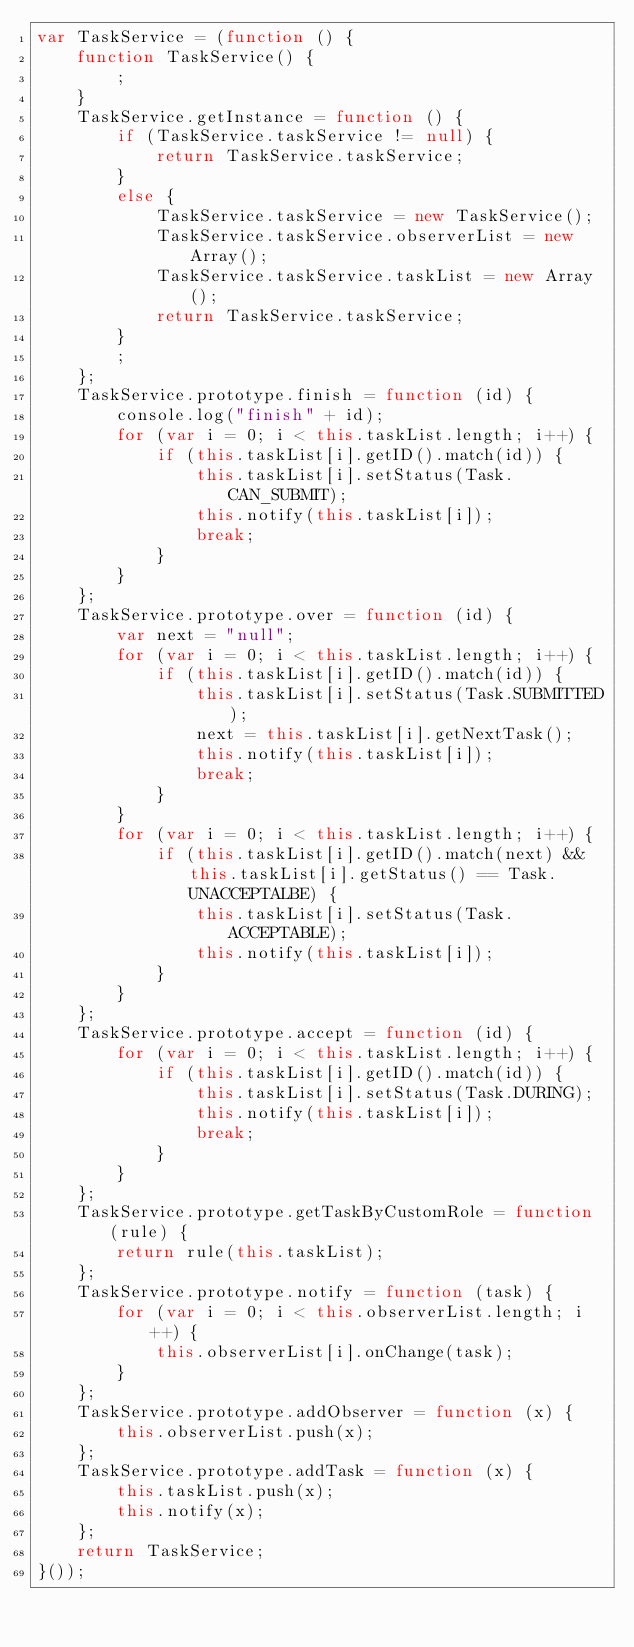Convert code to text. <code><loc_0><loc_0><loc_500><loc_500><_JavaScript_>var TaskService = (function () {
    function TaskService() {
        ;
    }
    TaskService.getInstance = function () {
        if (TaskService.taskService != null) {
            return TaskService.taskService;
        }
        else {
            TaskService.taskService = new TaskService();
            TaskService.taskService.observerList = new Array();
            TaskService.taskService.taskList = new Array();
            return TaskService.taskService;
        }
        ;
    };
    TaskService.prototype.finish = function (id) {
        console.log("finish" + id);
        for (var i = 0; i < this.taskList.length; i++) {
            if (this.taskList[i].getID().match(id)) {
                this.taskList[i].setStatus(Task.CAN_SUBMIT);
                this.notify(this.taskList[i]);
                break;
            }
        }
    };
    TaskService.prototype.over = function (id) {
        var next = "null";
        for (var i = 0; i < this.taskList.length; i++) {
            if (this.taskList[i].getID().match(id)) {
                this.taskList[i].setStatus(Task.SUBMITTED);
                next = this.taskList[i].getNextTask();
                this.notify(this.taskList[i]);
                break;
            }
        }
        for (var i = 0; i < this.taskList.length; i++) {
            if (this.taskList[i].getID().match(next) && this.taskList[i].getStatus() == Task.UNACCEPTALBE) {
                this.taskList[i].setStatus(Task.ACCEPTABLE);
                this.notify(this.taskList[i]);
            }
        }
    };
    TaskService.prototype.accept = function (id) {
        for (var i = 0; i < this.taskList.length; i++) {
            if (this.taskList[i].getID().match(id)) {
                this.taskList[i].setStatus(Task.DURING);
                this.notify(this.taskList[i]);
                break;
            }
        }
    };
    TaskService.prototype.getTaskByCustomRole = function (rule) {
        return rule(this.taskList);
    };
    TaskService.prototype.notify = function (task) {
        for (var i = 0; i < this.observerList.length; i++) {
            this.observerList[i].onChange(task);
        }
    };
    TaskService.prototype.addObserver = function (x) {
        this.observerList.push(x);
    };
    TaskService.prototype.addTask = function (x) {
        this.taskList.push(x);
        this.notify(x);
    };
    return TaskService;
}());
</code> 